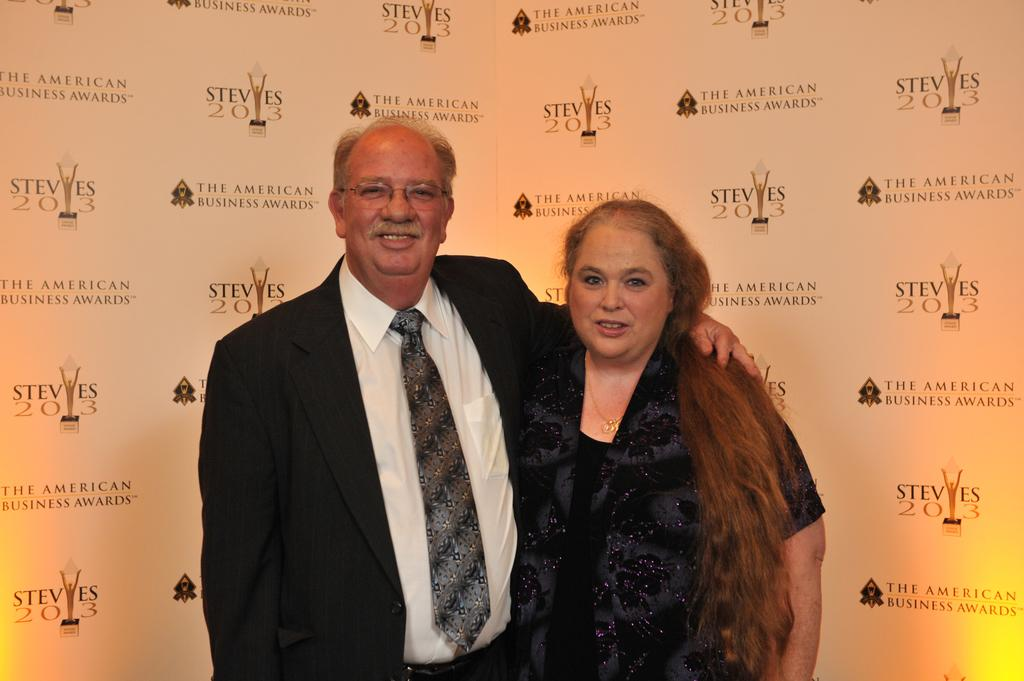How many people are in the image? There are two people in the image, a man and a woman. What are the people in the image doing? Both the man and the woman are standing and smiling. What can be seen in the background of the image? There are logos and text in the background of the image. What type of whip is being used by the man in the image? There is no whip present in the image; the man is simply standing and smiling. 